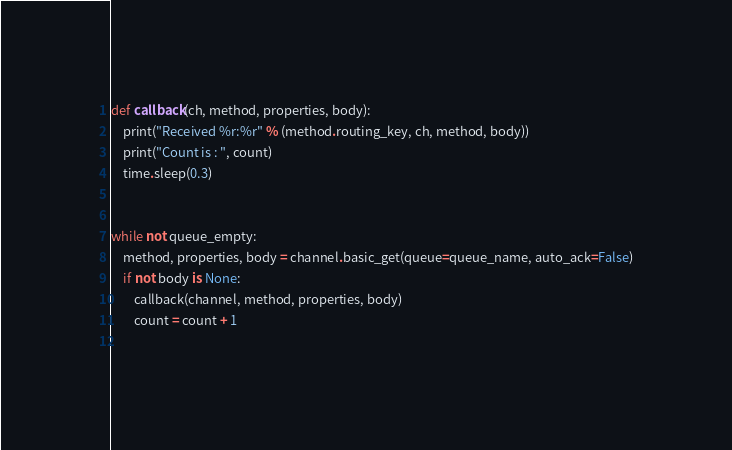Convert code to text. <code><loc_0><loc_0><loc_500><loc_500><_Python_>
def callback(ch, method, properties, body):
    print("Received %r:%r" % (method.routing_key, ch, method, body))
    print("Count is : ", count)
    time.sleep(0.3)


while not queue_empty:
    method, properties, body = channel.basic_get(queue=queue_name, auto_ack=False)
    if not body is None:
        callback(channel, method, properties, body)
        count = count + 1
       
</code> 